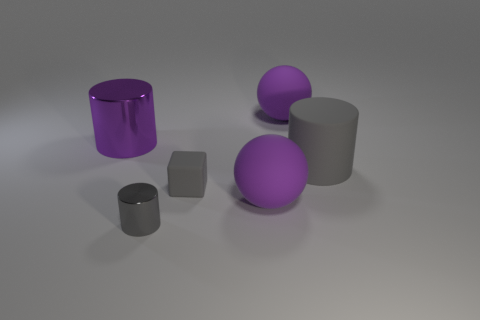Subtract all metal cylinders. How many cylinders are left? 1 Subtract 1 cubes. How many cubes are left? 0 Subtract all gray spheres. How many gray cylinders are left? 2 Subtract all purple cylinders. How many cylinders are left? 2 Add 3 large purple objects. How many objects exist? 9 Subtract all cubes. How many objects are left? 5 Subtract all tiny yellow metal objects. Subtract all large purple balls. How many objects are left? 4 Add 3 purple matte spheres. How many purple matte spheres are left? 5 Add 1 large purple rubber cubes. How many large purple rubber cubes exist? 1 Subtract 2 gray cylinders. How many objects are left? 4 